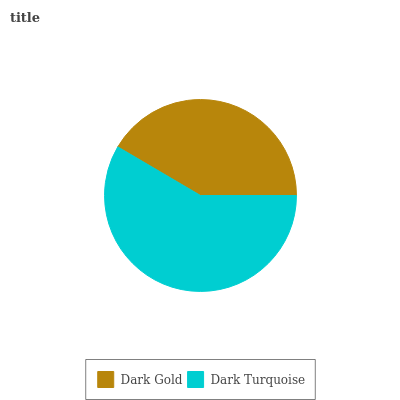Is Dark Gold the minimum?
Answer yes or no. Yes. Is Dark Turquoise the maximum?
Answer yes or no. Yes. Is Dark Turquoise the minimum?
Answer yes or no. No. Is Dark Turquoise greater than Dark Gold?
Answer yes or no. Yes. Is Dark Gold less than Dark Turquoise?
Answer yes or no. Yes. Is Dark Gold greater than Dark Turquoise?
Answer yes or no. No. Is Dark Turquoise less than Dark Gold?
Answer yes or no. No. Is Dark Turquoise the high median?
Answer yes or no. Yes. Is Dark Gold the low median?
Answer yes or no. Yes. Is Dark Gold the high median?
Answer yes or no. No. Is Dark Turquoise the low median?
Answer yes or no. No. 